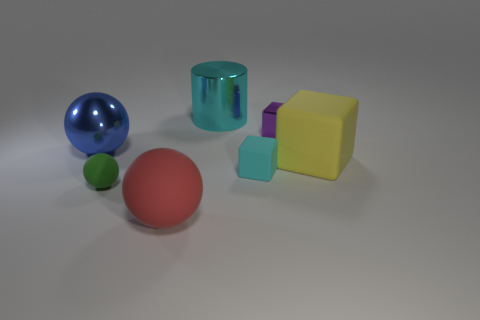Add 1 big yellow matte cubes. How many objects exist? 8 Subtract 2 cubes. How many cubes are left? 1 Subtract all green blocks. Subtract all gray spheres. How many blocks are left? 3 Subtract all gray cubes. How many red spheres are left? 1 Subtract all matte objects. Subtract all big yellow objects. How many objects are left? 2 Add 4 big metallic things. How many big metallic things are left? 6 Add 3 big red metal balls. How many big red metal balls exist? 3 Subtract all large rubber spheres. How many spheres are left? 2 Subtract 0 purple spheres. How many objects are left? 7 Subtract all cylinders. How many objects are left? 6 